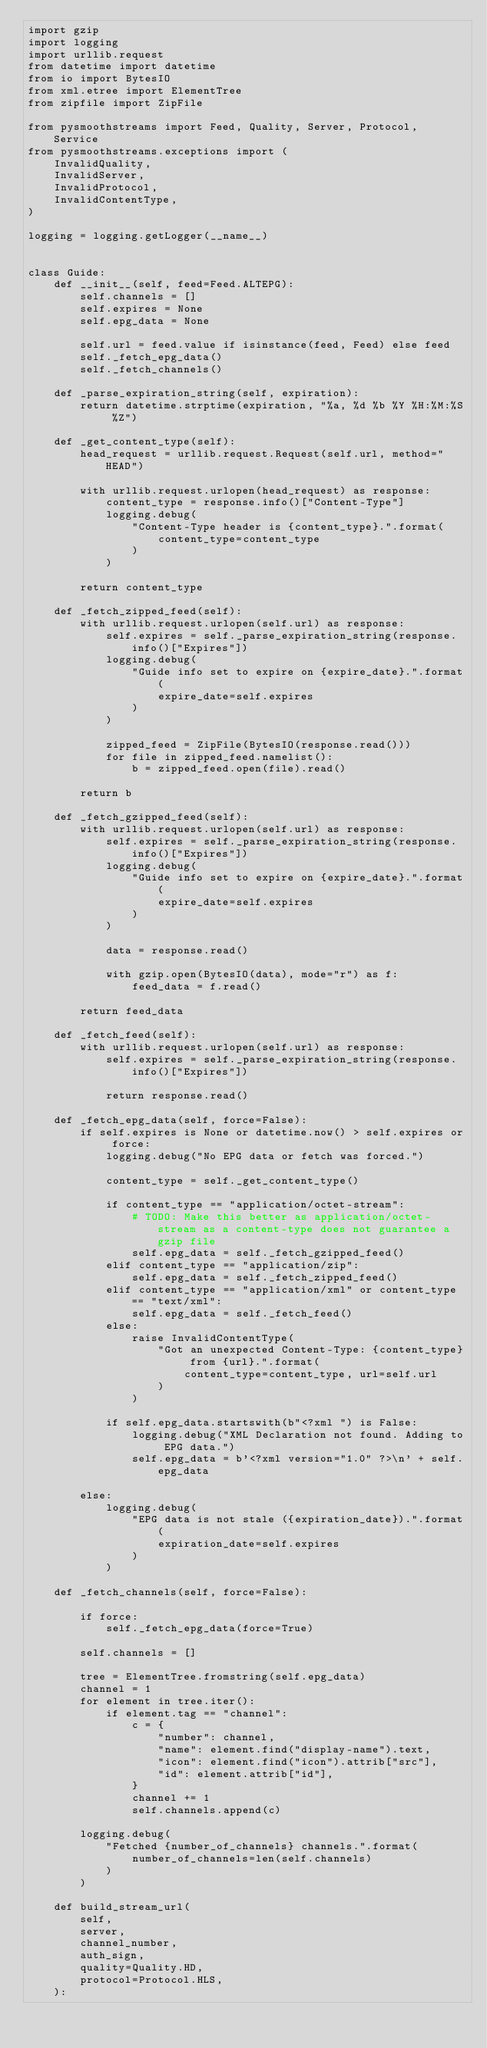<code> <loc_0><loc_0><loc_500><loc_500><_Python_>import gzip
import logging
import urllib.request
from datetime import datetime
from io import BytesIO
from xml.etree import ElementTree
from zipfile import ZipFile

from pysmoothstreams import Feed, Quality, Server, Protocol, Service
from pysmoothstreams.exceptions import (
    InvalidQuality,
    InvalidServer,
    InvalidProtocol,
    InvalidContentType,
)

logging = logging.getLogger(__name__)


class Guide:
    def __init__(self, feed=Feed.ALTEPG):
        self.channels = []
        self.expires = None
        self.epg_data = None

        self.url = feed.value if isinstance(feed, Feed) else feed
        self._fetch_epg_data()
        self._fetch_channels()

    def _parse_expiration_string(self, expiration):
        return datetime.strptime(expiration, "%a, %d %b %Y %H:%M:%S %Z")

    def _get_content_type(self):
        head_request = urllib.request.Request(self.url, method="HEAD")

        with urllib.request.urlopen(head_request) as response:
            content_type = response.info()["Content-Type"]
            logging.debug(
                "Content-Type header is {content_type}.".format(
                    content_type=content_type
                )
            )

        return content_type

    def _fetch_zipped_feed(self):
        with urllib.request.urlopen(self.url) as response:
            self.expires = self._parse_expiration_string(response.info()["Expires"])
            logging.debug(
                "Guide info set to expire on {expire_date}.".format(
                    expire_date=self.expires
                )
            )

            zipped_feed = ZipFile(BytesIO(response.read()))
            for file in zipped_feed.namelist():
                b = zipped_feed.open(file).read()

        return b

    def _fetch_gzipped_feed(self):
        with urllib.request.urlopen(self.url) as response:
            self.expires = self._parse_expiration_string(response.info()["Expires"])
            logging.debug(
                "Guide info set to expire on {expire_date}.".format(
                    expire_date=self.expires
                )
            )

            data = response.read()

            with gzip.open(BytesIO(data), mode="r") as f:
                feed_data = f.read()

        return feed_data

    def _fetch_feed(self):
        with urllib.request.urlopen(self.url) as response:
            self.expires = self._parse_expiration_string(response.info()["Expires"])

            return response.read()

    def _fetch_epg_data(self, force=False):
        if self.expires is None or datetime.now() > self.expires or force:
            logging.debug("No EPG data or fetch was forced.")

            content_type = self._get_content_type()

            if content_type == "application/octet-stream":
                # TODO: Make this better as application/octet-stream as a content-type does not guarantee a gzip file
                self.epg_data = self._fetch_gzipped_feed()
            elif content_type == "application/zip":
                self.epg_data = self._fetch_zipped_feed()
            elif content_type == "application/xml" or content_type == "text/xml":
                self.epg_data = self._fetch_feed()
            else:
                raise InvalidContentType(
                    "Got an unexpected Content-Type: {content_type} from {url}.".format(
                        content_type=content_type, url=self.url
                    )
                )

            if self.epg_data.startswith(b"<?xml ") is False:
                logging.debug("XML Declaration not found. Adding to EPG data.")
                self.epg_data = b'<?xml version="1.0" ?>\n' + self.epg_data

        else:
            logging.debug(
                "EPG data is not stale ({expiration_date}).".format(
                    expiration_date=self.expires
                )
            )

    def _fetch_channels(self, force=False):

        if force:
            self._fetch_epg_data(force=True)

        self.channels = []

        tree = ElementTree.fromstring(self.epg_data)
        channel = 1
        for element in tree.iter():
            if element.tag == "channel":
                c = {
                    "number": channel,
                    "name": element.find("display-name").text,
                    "icon": element.find("icon").attrib["src"],
                    "id": element.attrib["id"],
                }
                channel += 1
                self.channels.append(c)

        logging.debug(
            "Fetched {number_of_channels} channels.".format(
                number_of_channels=len(self.channels)
            )
        )

    def build_stream_url(
        self,
        server,
        channel_number,
        auth_sign,
        quality=Quality.HD,
        protocol=Protocol.HLS,
    ):</code> 